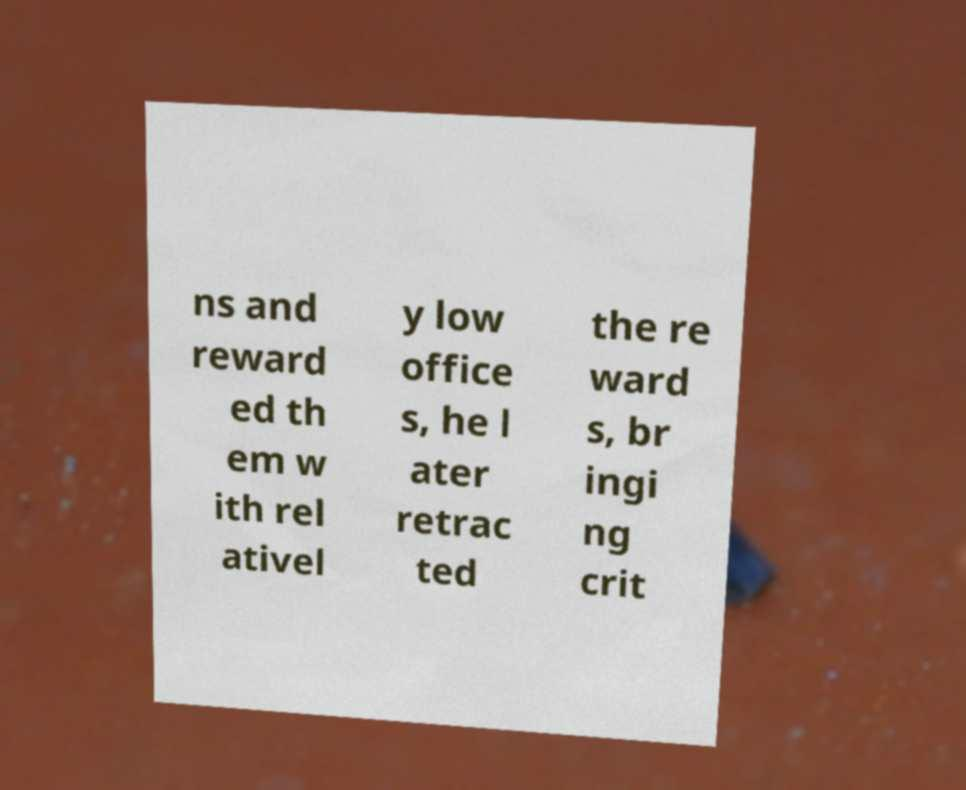What messages or text are displayed in this image? I need them in a readable, typed format. ns and reward ed th em w ith rel ativel y low office s, he l ater retrac ted the re ward s, br ingi ng crit 